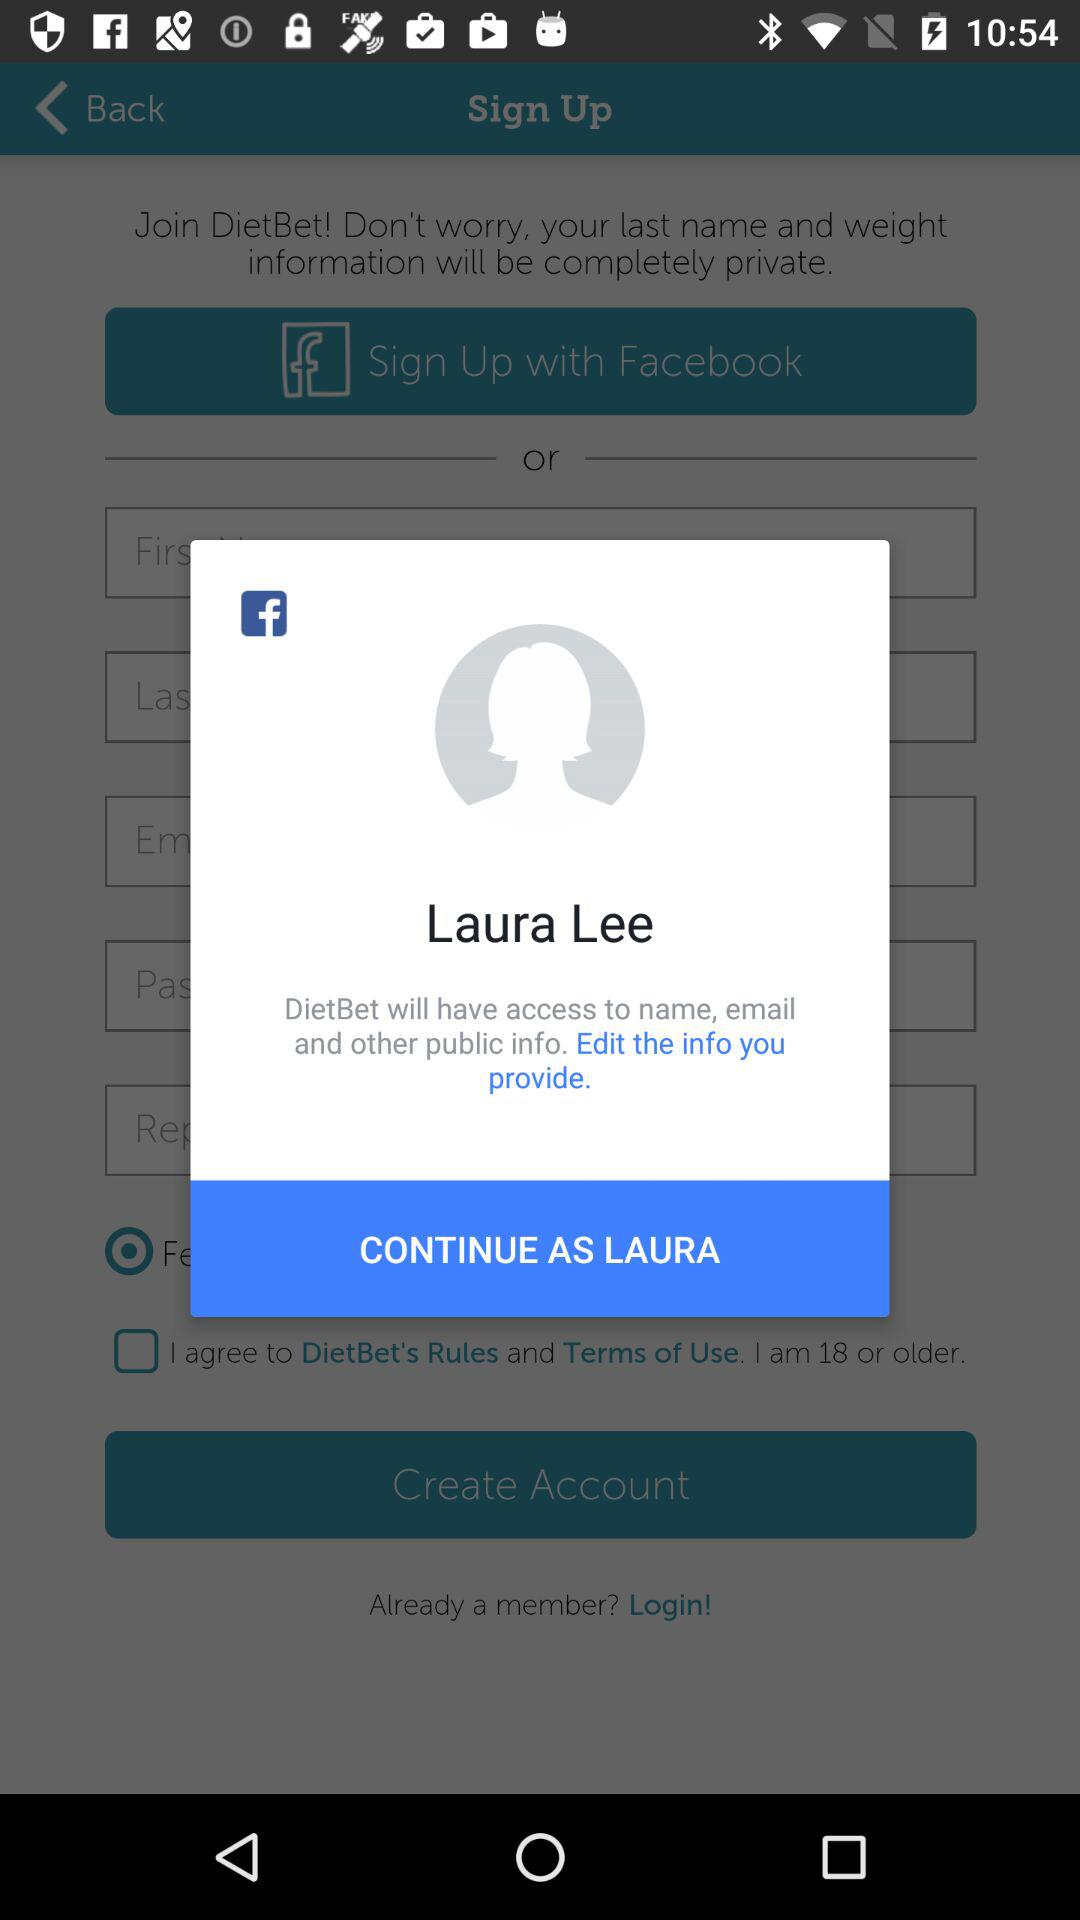What application has asked for permission? The application that has asked for permission is "DietBet". 